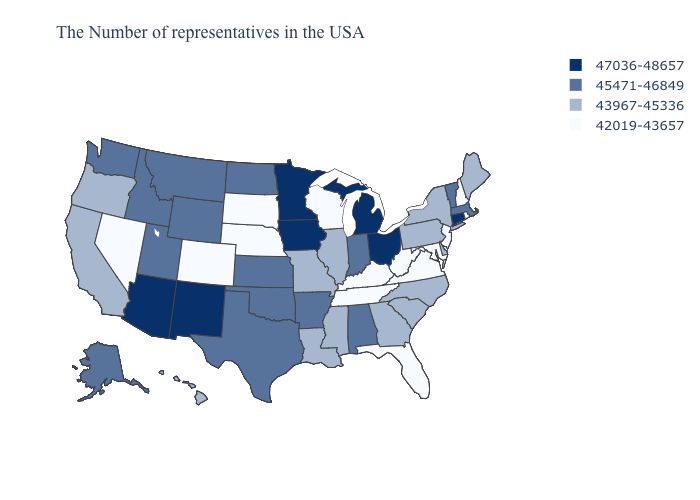Which states hav the highest value in the South?
Write a very short answer. Alabama, Arkansas, Oklahoma, Texas. Which states have the lowest value in the West?
Keep it brief. Colorado, Nevada. Does Ohio have the highest value in the USA?
Short answer required. Yes. Is the legend a continuous bar?
Keep it brief. No. Does Michigan have the highest value in the MidWest?
Keep it brief. Yes. Name the states that have a value in the range 45471-46849?
Concise answer only. Massachusetts, Vermont, Indiana, Alabama, Arkansas, Kansas, Oklahoma, Texas, North Dakota, Wyoming, Utah, Montana, Idaho, Washington, Alaska. What is the value of Nevada?
Be succinct. 42019-43657. Does Tennessee have a lower value than West Virginia?
Short answer required. No. Which states hav the highest value in the Northeast?
Quick response, please. Connecticut. What is the lowest value in the USA?
Give a very brief answer. 42019-43657. Name the states that have a value in the range 43967-45336?
Answer briefly. Maine, New York, Delaware, Pennsylvania, North Carolina, South Carolina, Georgia, Illinois, Mississippi, Louisiana, Missouri, California, Oregon, Hawaii. What is the highest value in the USA?
Concise answer only. 47036-48657. Name the states that have a value in the range 47036-48657?
Short answer required. Connecticut, Ohio, Michigan, Minnesota, Iowa, New Mexico, Arizona. Among the states that border Maryland , does West Virginia have the lowest value?
Keep it brief. Yes. Name the states that have a value in the range 42019-43657?
Give a very brief answer. Rhode Island, New Hampshire, New Jersey, Maryland, Virginia, West Virginia, Florida, Kentucky, Tennessee, Wisconsin, Nebraska, South Dakota, Colorado, Nevada. 